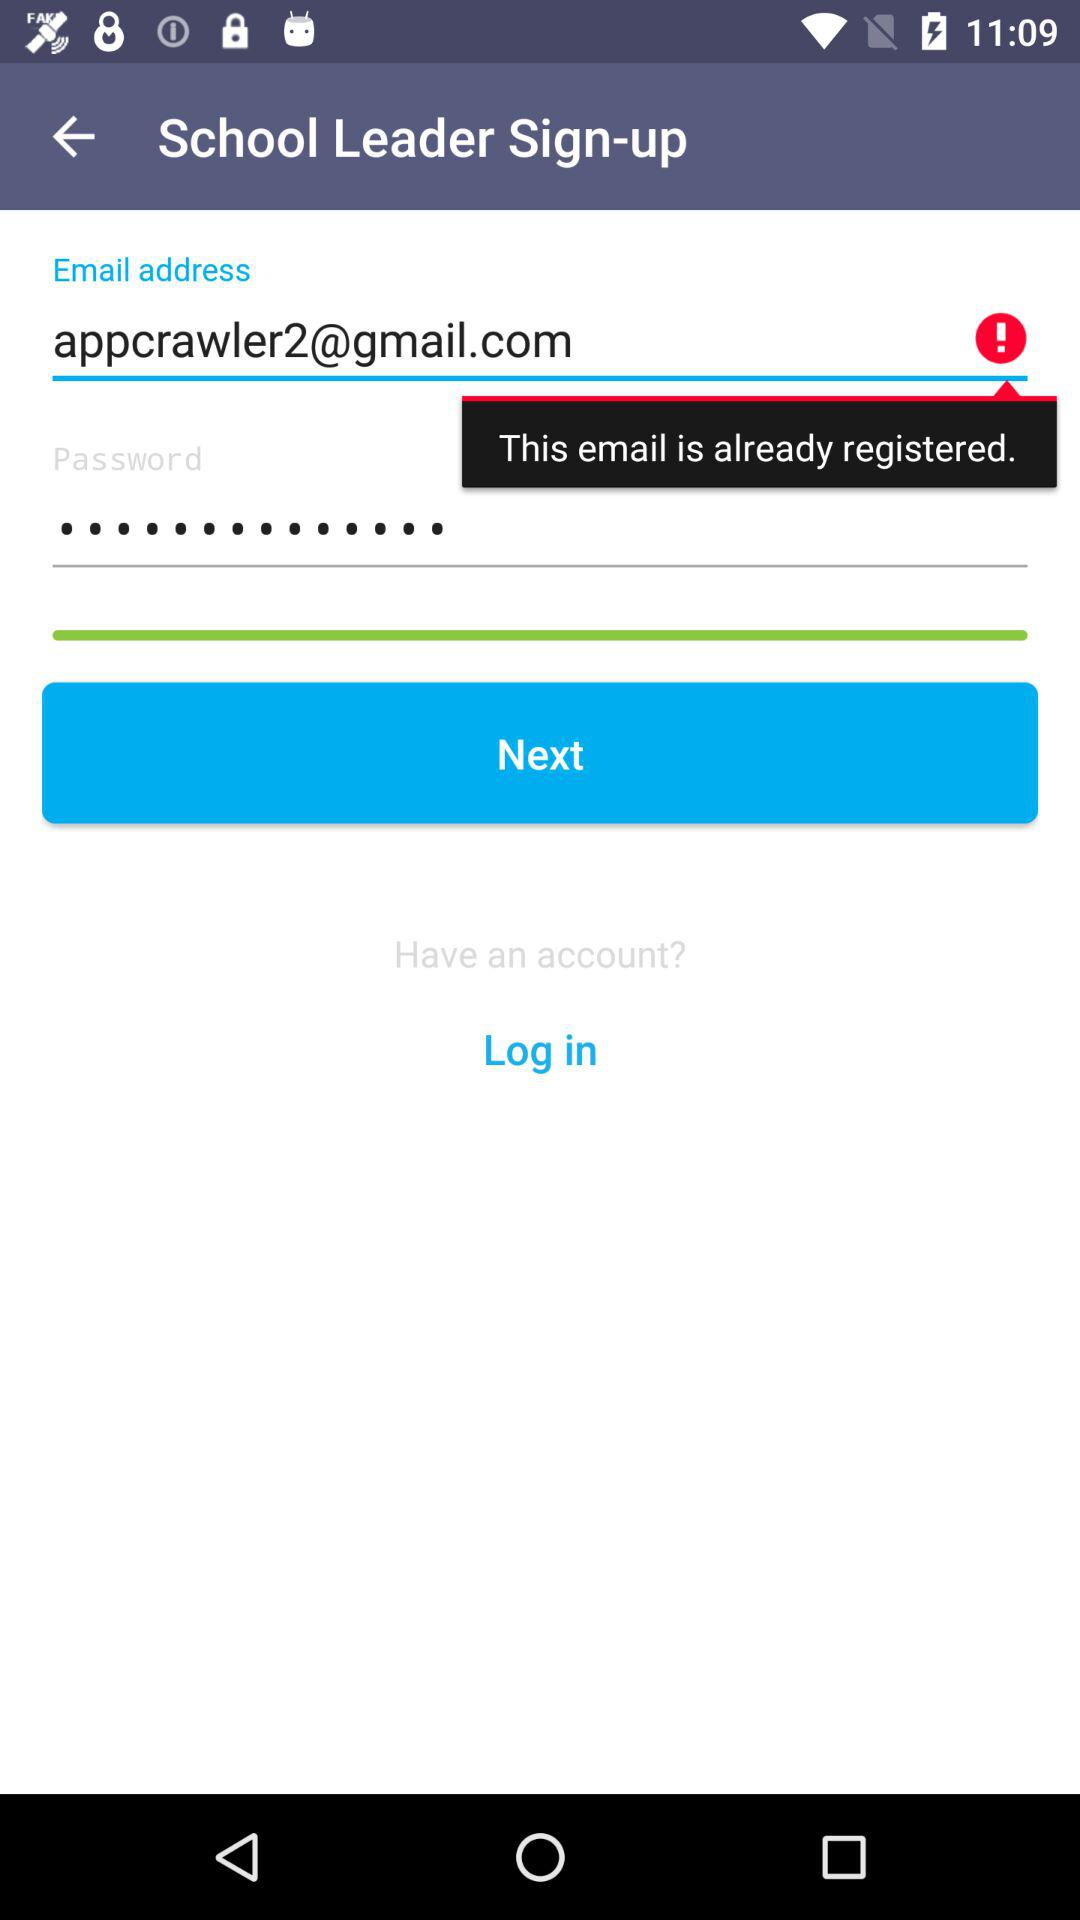How many text inputs have an error message?
Answer the question using a single word or phrase. 1 